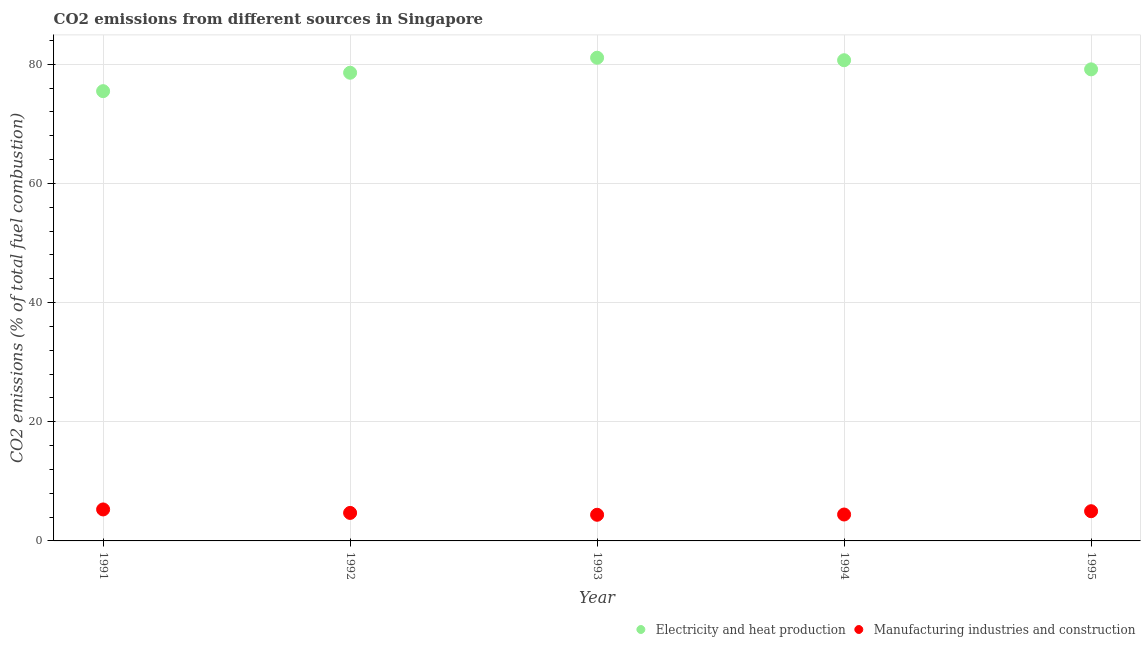How many different coloured dotlines are there?
Offer a terse response. 2. What is the co2 emissions due to manufacturing industries in 1994?
Your answer should be very brief. 4.43. Across all years, what is the maximum co2 emissions due to manufacturing industries?
Make the answer very short. 5.28. Across all years, what is the minimum co2 emissions due to electricity and heat production?
Offer a very short reply. 75.5. In which year was the co2 emissions due to electricity and heat production minimum?
Provide a succinct answer. 1991. What is the total co2 emissions due to electricity and heat production in the graph?
Your answer should be compact. 395.03. What is the difference between the co2 emissions due to electricity and heat production in 1991 and that in 1993?
Provide a short and direct response. -5.61. What is the difference between the co2 emissions due to electricity and heat production in 1993 and the co2 emissions due to manufacturing industries in 1991?
Offer a very short reply. 75.82. What is the average co2 emissions due to manufacturing industries per year?
Give a very brief answer. 4.76. In the year 1991, what is the difference between the co2 emissions due to manufacturing industries and co2 emissions due to electricity and heat production?
Ensure brevity in your answer.  -70.21. What is the ratio of the co2 emissions due to electricity and heat production in 1993 to that in 1995?
Your answer should be compact. 1.02. Is the difference between the co2 emissions due to manufacturing industries in 1994 and 1995 greater than the difference between the co2 emissions due to electricity and heat production in 1994 and 1995?
Your answer should be very brief. No. What is the difference between the highest and the second highest co2 emissions due to manufacturing industries?
Ensure brevity in your answer.  0.3. What is the difference between the highest and the lowest co2 emissions due to electricity and heat production?
Offer a very short reply. 5.61. Is the sum of the co2 emissions due to electricity and heat production in 1991 and 1995 greater than the maximum co2 emissions due to manufacturing industries across all years?
Ensure brevity in your answer.  Yes. Is the co2 emissions due to electricity and heat production strictly greater than the co2 emissions due to manufacturing industries over the years?
Give a very brief answer. Yes. How many dotlines are there?
Provide a succinct answer. 2. Are the values on the major ticks of Y-axis written in scientific E-notation?
Your answer should be compact. No. Where does the legend appear in the graph?
Your answer should be compact. Bottom right. How many legend labels are there?
Provide a short and direct response. 2. What is the title of the graph?
Make the answer very short. CO2 emissions from different sources in Singapore. What is the label or title of the Y-axis?
Give a very brief answer. CO2 emissions (% of total fuel combustion). What is the CO2 emissions (% of total fuel combustion) in Electricity and heat production in 1991?
Give a very brief answer. 75.5. What is the CO2 emissions (% of total fuel combustion) of Manufacturing industries and construction in 1991?
Ensure brevity in your answer.  5.28. What is the CO2 emissions (% of total fuel combustion) of Electricity and heat production in 1992?
Give a very brief answer. 78.59. What is the CO2 emissions (% of total fuel combustion) in Manufacturing industries and construction in 1992?
Make the answer very short. 4.7. What is the CO2 emissions (% of total fuel combustion) of Electricity and heat production in 1993?
Your response must be concise. 81.11. What is the CO2 emissions (% of total fuel combustion) in Manufacturing industries and construction in 1993?
Your response must be concise. 4.39. What is the CO2 emissions (% of total fuel combustion) in Electricity and heat production in 1994?
Provide a short and direct response. 80.69. What is the CO2 emissions (% of total fuel combustion) in Manufacturing industries and construction in 1994?
Give a very brief answer. 4.43. What is the CO2 emissions (% of total fuel combustion) of Electricity and heat production in 1995?
Your answer should be compact. 79.16. What is the CO2 emissions (% of total fuel combustion) of Manufacturing industries and construction in 1995?
Provide a succinct answer. 4.99. Across all years, what is the maximum CO2 emissions (% of total fuel combustion) in Electricity and heat production?
Offer a terse response. 81.11. Across all years, what is the maximum CO2 emissions (% of total fuel combustion) in Manufacturing industries and construction?
Offer a terse response. 5.28. Across all years, what is the minimum CO2 emissions (% of total fuel combustion) of Electricity and heat production?
Your answer should be compact. 75.5. Across all years, what is the minimum CO2 emissions (% of total fuel combustion) in Manufacturing industries and construction?
Give a very brief answer. 4.39. What is the total CO2 emissions (% of total fuel combustion) of Electricity and heat production in the graph?
Your answer should be compact. 395.03. What is the total CO2 emissions (% of total fuel combustion) of Manufacturing industries and construction in the graph?
Make the answer very short. 23.79. What is the difference between the CO2 emissions (% of total fuel combustion) of Electricity and heat production in 1991 and that in 1992?
Your response must be concise. -3.09. What is the difference between the CO2 emissions (% of total fuel combustion) in Manufacturing industries and construction in 1991 and that in 1992?
Provide a succinct answer. 0.58. What is the difference between the CO2 emissions (% of total fuel combustion) of Electricity and heat production in 1991 and that in 1993?
Make the answer very short. -5.61. What is the difference between the CO2 emissions (% of total fuel combustion) in Manufacturing industries and construction in 1991 and that in 1993?
Make the answer very short. 0.9. What is the difference between the CO2 emissions (% of total fuel combustion) of Electricity and heat production in 1991 and that in 1994?
Your response must be concise. -5.19. What is the difference between the CO2 emissions (% of total fuel combustion) of Manufacturing industries and construction in 1991 and that in 1994?
Provide a succinct answer. 0.85. What is the difference between the CO2 emissions (% of total fuel combustion) in Electricity and heat production in 1991 and that in 1995?
Provide a short and direct response. -3.66. What is the difference between the CO2 emissions (% of total fuel combustion) in Manufacturing industries and construction in 1991 and that in 1995?
Give a very brief answer. 0.3. What is the difference between the CO2 emissions (% of total fuel combustion) in Electricity and heat production in 1992 and that in 1993?
Your answer should be compact. -2.52. What is the difference between the CO2 emissions (% of total fuel combustion) of Manufacturing industries and construction in 1992 and that in 1993?
Give a very brief answer. 0.31. What is the difference between the CO2 emissions (% of total fuel combustion) of Electricity and heat production in 1992 and that in 1994?
Ensure brevity in your answer.  -2.1. What is the difference between the CO2 emissions (% of total fuel combustion) in Manufacturing industries and construction in 1992 and that in 1994?
Give a very brief answer. 0.27. What is the difference between the CO2 emissions (% of total fuel combustion) in Electricity and heat production in 1992 and that in 1995?
Your response must be concise. -0.57. What is the difference between the CO2 emissions (% of total fuel combustion) of Manufacturing industries and construction in 1992 and that in 1995?
Offer a terse response. -0.29. What is the difference between the CO2 emissions (% of total fuel combustion) of Electricity and heat production in 1993 and that in 1994?
Offer a terse response. 0.42. What is the difference between the CO2 emissions (% of total fuel combustion) in Manufacturing industries and construction in 1993 and that in 1994?
Provide a short and direct response. -0.04. What is the difference between the CO2 emissions (% of total fuel combustion) of Electricity and heat production in 1993 and that in 1995?
Keep it short and to the point. 1.95. What is the difference between the CO2 emissions (% of total fuel combustion) of Manufacturing industries and construction in 1993 and that in 1995?
Offer a very short reply. -0.6. What is the difference between the CO2 emissions (% of total fuel combustion) in Electricity and heat production in 1994 and that in 1995?
Ensure brevity in your answer.  1.53. What is the difference between the CO2 emissions (% of total fuel combustion) in Manufacturing industries and construction in 1994 and that in 1995?
Ensure brevity in your answer.  -0.55. What is the difference between the CO2 emissions (% of total fuel combustion) of Electricity and heat production in 1991 and the CO2 emissions (% of total fuel combustion) of Manufacturing industries and construction in 1992?
Offer a very short reply. 70.8. What is the difference between the CO2 emissions (% of total fuel combustion) of Electricity and heat production in 1991 and the CO2 emissions (% of total fuel combustion) of Manufacturing industries and construction in 1993?
Provide a succinct answer. 71.11. What is the difference between the CO2 emissions (% of total fuel combustion) of Electricity and heat production in 1991 and the CO2 emissions (% of total fuel combustion) of Manufacturing industries and construction in 1994?
Ensure brevity in your answer.  71.06. What is the difference between the CO2 emissions (% of total fuel combustion) of Electricity and heat production in 1991 and the CO2 emissions (% of total fuel combustion) of Manufacturing industries and construction in 1995?
Offer a terse response. 70.51. What is the difference between the CO2 emissions (% of total fuel combustion) in Electricity and heat production in 1992 and the CO2 emissions (% of total fuel combustion) in Manufacturing industries and construction in 1993?
Ensure brevity in your answer.  74.2. What is the difference between the CO2 emissions (% of total fuel combustion) in Electricity and heat production in 1992 and the CO2 emissions (% of total fuel combustion) in Manufacturing industries and construction in 1994?
Keep it short and to the point. 74.15. What is the difference between the CO2 emissions (% of total fuel combustion) of Electricity and heat production in 1992 and the CO2 emissions (% of total fuel combustion) of Manufacturing industries and construction in 1995?
Offer a terse response. 73.6. What is the difference between the CO2 emissions (% of total fuel combustion) in Electricity and heat production in 1993 and the CO2 emissions (% of total fuel combustion) in Manufacturing industries and construction in 1994?
Your answer should be very brief. 76.67. What is the difference between the CO2 emissions (% of total fuel combustion) in Electricity and heat production in 1993 and the CO2 emissions (% of total fuel combustion) in Manufacturing industries and construction in 1995?
Your response must be concise. 76.12. What is the difference between the CO2 emissions (% of total fuel combustion) in Electricity and heat production in 1994 and the CO2 emissions (% of total fuel combustion) in Manufacturing industries and construction in 1995?
Offer a terse response. 75.7. What is the average CO2 emissions (% of total fuel combustion) in Electricity and heat production per year?
Offer a terse response. 79.01. What is the average CO2 emissions (% of total fuel combustion) in Manufacturing industries and construction per year?
Ensure brevity in your answer.  4.76. In the year 1991, what is the difference between the CO2 emissions (% of total fuel combustion) of Electricity and heat production and CO2 emissions (% of total fuel combustion) of Manufacturing industries and construction?
Offer a terse response. 70.21. In the year 1992, what is the difference between the CO2 emissions (% of total fuel combustion) of Electricity and heat production and CO2 emissions (% of total fuel combustion) of Manufacturing industries and construction?
Provide a succinct answer. 73.89. In the year 1993, what is the difference between the CO2 emissions (% of total fuel combustion) of Electricity and heat production and CO2 emissions (% of total fuel combustion) of Manufacturing industries and construction?
Offer a very short reply. 76.72. In the year 1994, what is the difference between the CO2 emissions (% of total fuel combustion) in Electricity and heat production and CO2 emissions (% of total fuel combustion) in Manufacturing industries and construction?
Provide a succinct answer. 76.25. In the year 1995, what is the difference between the CO2 emissions (% of total fuel combustion) of Electricity and heat production and CO2 emissions (% of total fuel combustion) of Manufacturing industries and construction?
Provide a short and direct response. 74.17. What is the ratio of the CO2 emissions (% of total fuel combustion) of Electricity and heat production in 1991 to that in 1992?
Keep it short and to the point. 0.96. What is the ratio of the CO2 emissions (% of total fuel combustion) of Manufacturing industries and construction in 1991 to that in 1992?
Make the answer very short. 1.12. What is the ratio of the CO2 emissions (% of total fuel combustion) in Electricity and heat production in 1991 to that in 1993?
Your answer should be very brief. 0.93. What is the ratio of the CO2 emissions (% of total fuel combustion) of Manufacturing industries and construction in 1991 to that in 1993?
Give a very brief answer. 1.2. What is the ratio of the CO2 emissions (% of total fuel combustion) of Electricity and heat production in 1991 to that in 1994?
Your response must be concise. 0.94. What is the ratio of the CO2 emissions (% of total fuel combustion) in Manufacturing industries and construction in 1991 to that in 1994?
Offer a very short reply. 1.19. What is the ratio of the CO2 emissions (% of total fuel combustion) of Electricity and heat production in 1991 to that in 1995?
Offer a terse response. 0.95. What is the ratio of the CO2 emissions (% of total fuel combustion) of Manufacturing industries and construction in 1991 to that in 1995?
Your response must be concise. 1.06. What is the ratio of the CO2 emissions (% of total fuel combustion) of Electricity and heat production in 1992 to that in 1993?
Offer a terse response. 0.97. What is the ratio of the CO2 emissions (% of total fuel combustion) in Manufacturing industries and construction in 1992 to that in 1993?
Your answer should be very brief. 1.07. What is the ratio of the CO2 emissions (% of total fuel combustion) in Manufacturing industries and construction in 1992 to that in 1994?
Provide a short and direct response. 1.06. What is the ratio of the CO2 emissions (% of total fuel combustion) of Electricity and heat production in 1992 to that in 1995?
Provide a succinct answer. 0.99. What is the ratio of the CO2 emissions (% of total fuel combustion) in Manufacturing industries and construction in 1992 to that in 1995?
Your answer should be compact. 0.94. What is the ratio of the CO2 emissions (% of total fuel combustion) of Manufacturing industries and construction in 1993 to that in 1994?
Give a very brief answer. 0.99. What is the ratio of the CO2 emissions (% of total fuel combustion) of Electricity and heat production in 1993 to that in 1995?
Your answer should be compact. 1.02. What is the ratio of the CO2 emissions (% of total fuel combustion) in Electricity and heat production in 1994 to that in 1995?
Make the answer very short. 1.02. What is the difference between the highest and the second highest CO2 emissions (% of total fuel combustion) of Electricity and heat production?
Make the answer very short. 0.42. What is the difference between the highest and the second highest CO2 emissions (% of total fuel combustion) in Manufacturing industries and construction?
Keep it short and to the point. 0.3. What is the difference between the highest and the lowest CO2 emissions (% of total fuel combustion) in Electricity and heat production?
Give a very brief answer. 5.61. What is the difference between the highest and the lowest CO2 emissions (% of total fuel combustion) of Manufacturing industries and construction?
Your response must be concise. 0.9. 